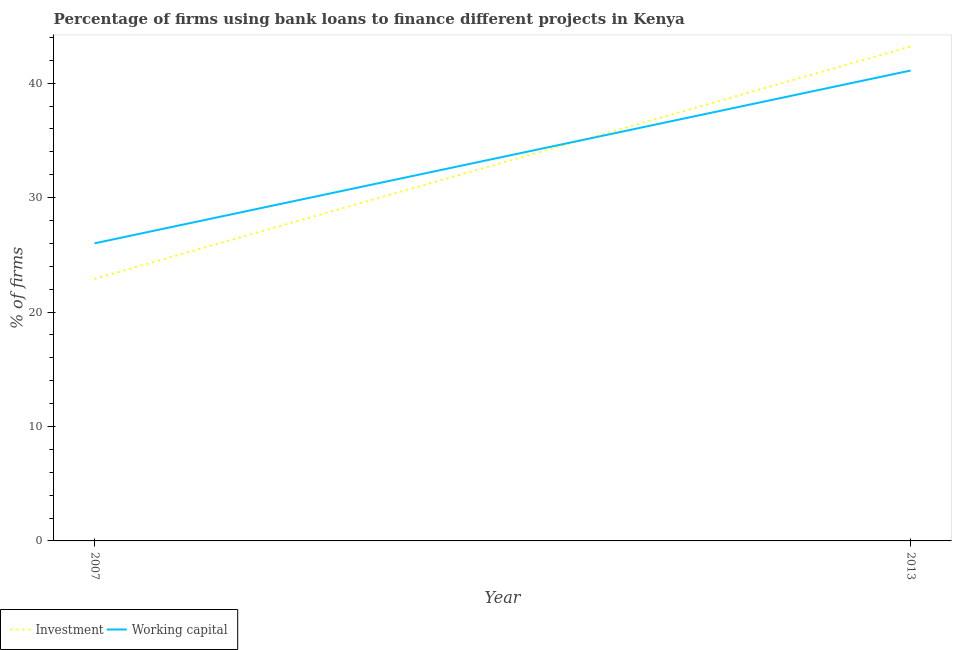How many different coloured lines are there?
Provide a succinct answer. 2. Across all years, what is the maximum percentage of firms using banks to finance investment?
Offer a terse response. 43.2. Across all years, what is the minimum percentage of firms using banks to finance working capital?
Your answer should be compact. 26. In which year was the percentage of firms using banks to finance working capital maximum?
Your response must be concise. 2013. In which year was the percentage of firms using banks to finance working capital minimum?
Ensure brevity in your answer.  2007. What is the total percentage of firms using banks to finance working capital in the graph?
Offer a terse response. 67.1. What is the difference between the percentage of firms using banks to finance investment in 2007 and that in 2013?
Keep it short and to the point. -20.3. What is the difference between the percentage of firms using banks to finance investment in 2013 and the percentage of firms using banks to finance working capital in 2007?
Make the answer very short. 17.2. What is the average percentage of firms using banks to finance investment per year?
Your answer should be very brief. 33.05. In the year 2007, what is the difference between the percentage of firms using banks to finance investment and percentage of firms using banks to finance working capital?
Your answer should be compact. -3.1. In how many years, is the percentage of firms using banks to finance investment greater than 26 %?
Offer a terse response. 1. What is the ratio of the percentage of firms using banks to finance investment in 2007 to that in 2013?
Your response must be concise. 0.53. Is the percentage of firms using banks to finance investment in 2007 less than that in 2013?
Your response must be concise. Yes. Is the percentage of firms using banks to finance working capital strictly greater than the percentage of firms using banks to finance investment over the years?
Make the answer very short. No. How many lines are there?
Offer a very short reply. 2. How many years are there in the graph?
Make the answer very short. 2. What is the difference between two consecutive major ticks on the Y-axis?
Give a very brief answer. 10. Are the values on the major ticks of Y-axis written in scientific E-notation?
Keep it short and to the point. No. Where does the legend appear in the graph?
Provide a short and direct response. Bottom left. How are the legend labels stacked?
Keep it short and to the point. Horizontal. What is the title of the graph?
Provide a short and direct response. Percentage of firms using bank loans to finance different projects in Kenya. What is the label or title of the Y-axis?
Ensure brevity in your answer.  % of firms. What is the % of firms of Investment in 2007?
Give a very brief answer. 22.9. What is the % of firms of Investment in 2013?
Make the answer very short. 43.2. What is the % of firms of Working capital in 2013?
Give a very brief answer. 41.1. Across all years, what is the maximum % of firms of Investment?
Make the answer very short. 43.2. Across all years, what is the maximum % of firms of Working capital?
Give a very brief answer. 41.1. Across all years, what is the minimum % of firms in Investment?
Make the answer very short. 22.9. Across all years, what is the minimum % of firms in Working capital?
Make the answer very short. 26. What is the total % of firms in Investment in the graph?
Your answer should be compact. 66.1. What is the total % of firms in Working capital in the graph?
Ensure brevity in your answer.  67.1. What is the difference between the % of firms in Investment in 2007 and that in 2013?
Your answer should be very brief. -20.3. What is the difference between the % of firms of Working capital in 2007 and that in 2013?
Make the answer very short. -15.1. What is the difference between the % of firms of Investment in 2007 and the % of firms of Working capital in 2013?
Ensure brevity in your answer.  -18.2. What is the average % of firms of Investment per year?
Give a very brief answer. 33.05. What is the average % of firms in Working capital per year?
Offer a terse response. 33.55. What is the ratio of the % of firms in Investment in 2007 to that in 2013?
Keep it short and to the point. 0.53. What is the ratio of the % of firms of Working capital in 2007 to that in 2013?
Ensure brevity in your answer.  0.63. What is the difference between the highest and the second highest % of firms of Investment?
Offer a very short reply. 20.3. What is the difference between the highest and the lowest % of firms in Investment?
Your answer should be very brief. 20.3. What is the difference between the highest and the lowest % of firms in Working capital?
Your response must be concise. 15.1. 